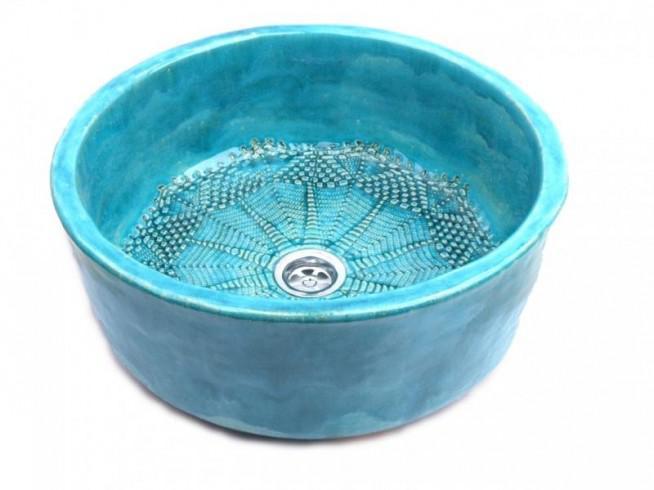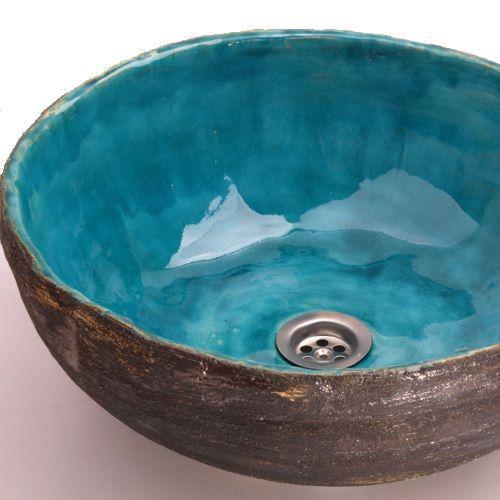The first image is the image on the left, the second image is the image on the right. Given the left and right images, does the statement "A gold-colored spout extends over a vessel sink with a decorated exterior set atop a tile counter in the left image, and the right image shows a sink with a hole inside." hold true? Answer yes or no. No. The first image is the image on the left, the second image is the image on the right. Analyze the images presented: Is the assertion "There is a sink bowl underneath a faucet." valid? Answer yes or no. No. 